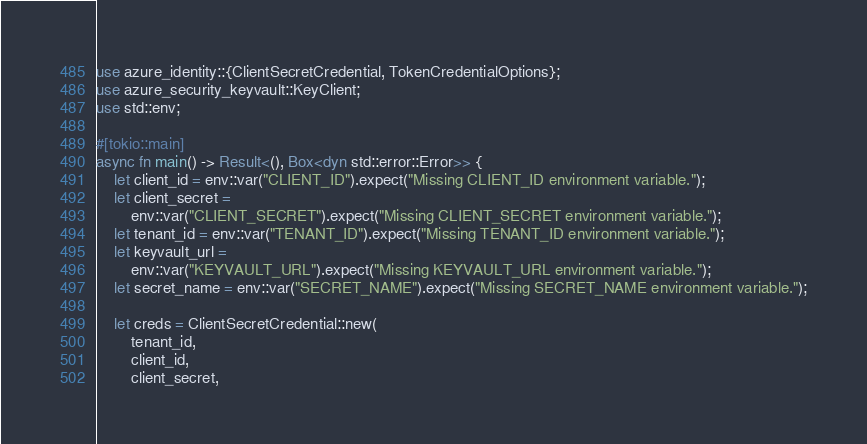<code> <loc_0><loc_0><loc_500><loc_500><_Rust_>use azure_identity::{ClientSecretCredential, TokenCredentialOptions};
use azure_security_keyvault::KeyClient;
use std::env;

#[tokio::main]
async fn main() -> Result<(), Box<dyn std::error::Error>> {
    let client_id = env::var("CLIENT_ID").expect("Missing CLIENT_ID environment variable.");
    let client_secret =
        env::var("CLIENT_SECRET").expect("Missing CLIENT_SECRET environment variable.");
    let tenant_id = env::var("TENANT_ID").expect("Missing TENANT_ID environment variable.");
    let keyvault_url =
        env::var("KEYVAULT_URL").expect("Missing KEYVAULT_URL environment variable.");
    let secret_name = env::var("SECRET_NAME").expect("Missing SECRET_NAME environment variable.");

    let creds = ClientSecretCredential::new(
        tenant_id,
        client_id,
        client_secret,</code> 